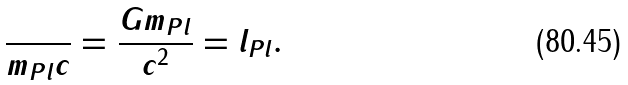<formula> <loc_0><loc_0><loc_500><loc_500>\frac { } { m _ { P l } c } = \frac { G m _ { P l } } { c ^ { 2 } } = l _ { P l } .</formula> 